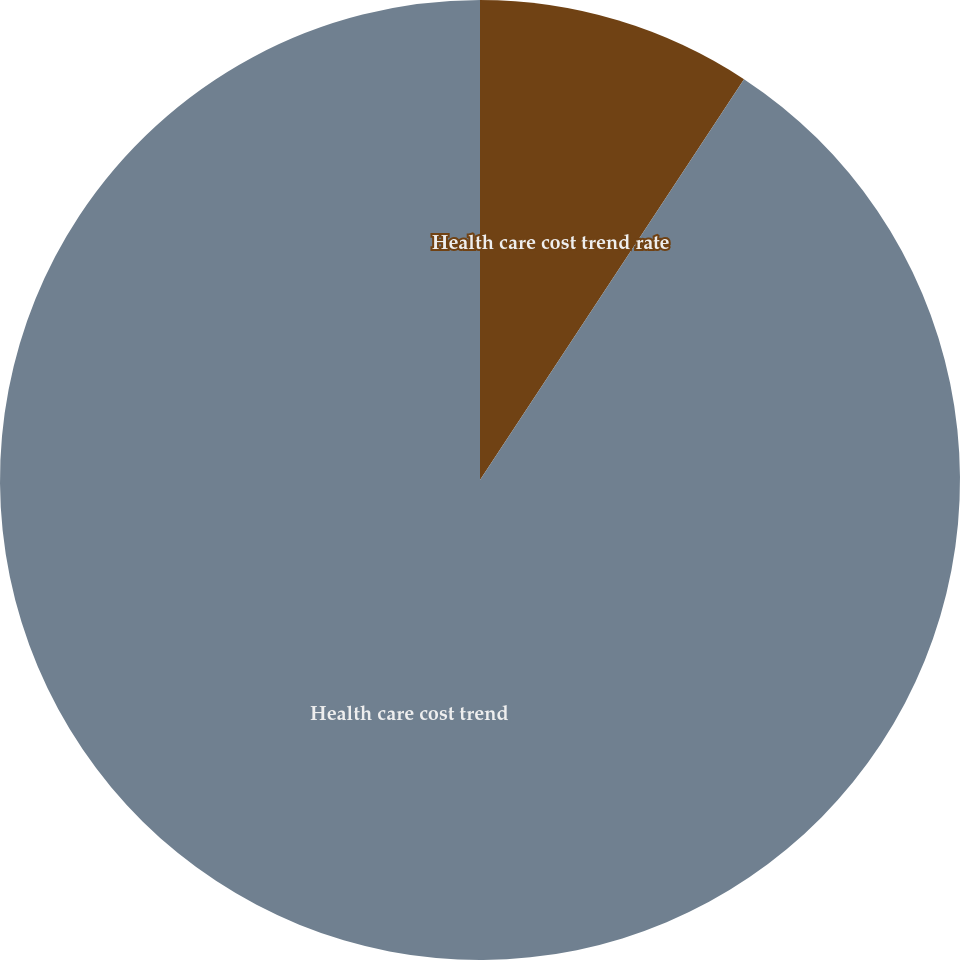Convert chart. <chart><loc_0><loc_0><loc_500><loc_500><pie_chart><fcel>Health care cost trend rate<fcel>Health care cost trend<nl><fcel>9.27%<fcel>90.73%<nl></chart> 